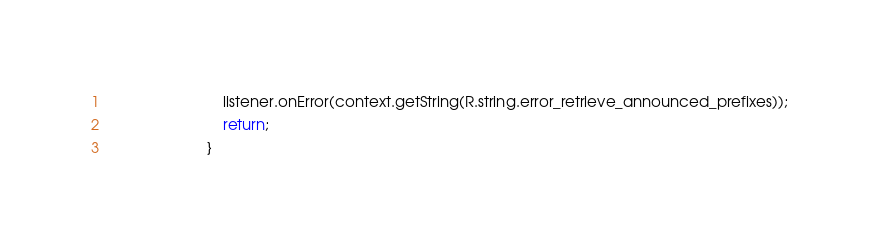<code> <loc_0><loc_0><loc_500><loc_500><_Java_>                            listener.onError(context.getString(R.string.error_retrieve_announced_prefixes));
                            return;
                        }</code> 